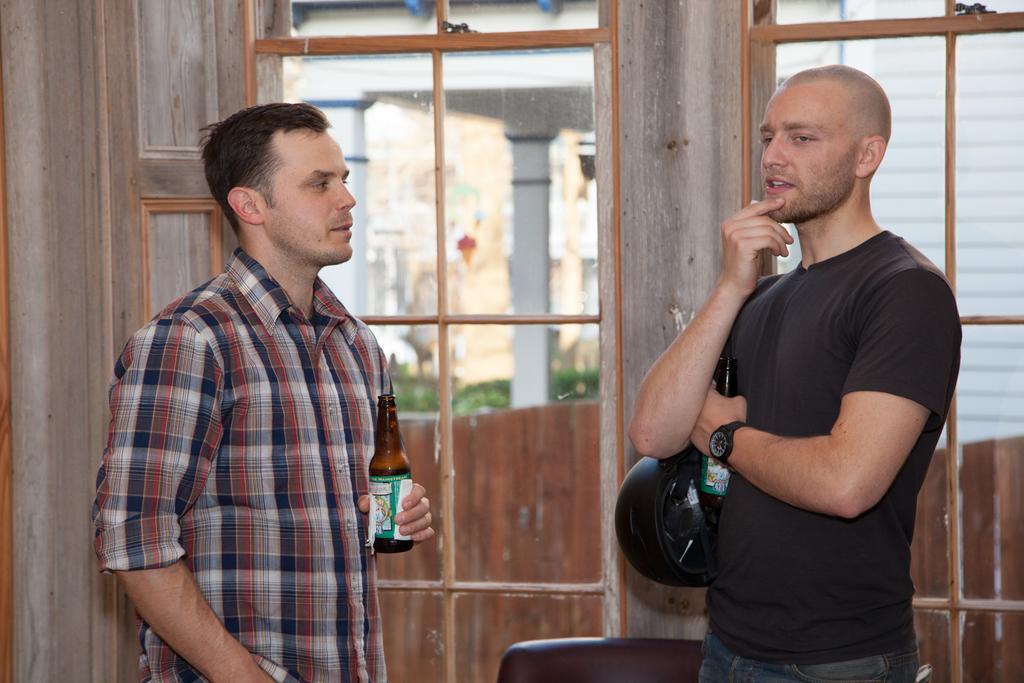Please provide a concise description of this image. In the given image i can see a people holding bottles,door and windows. 